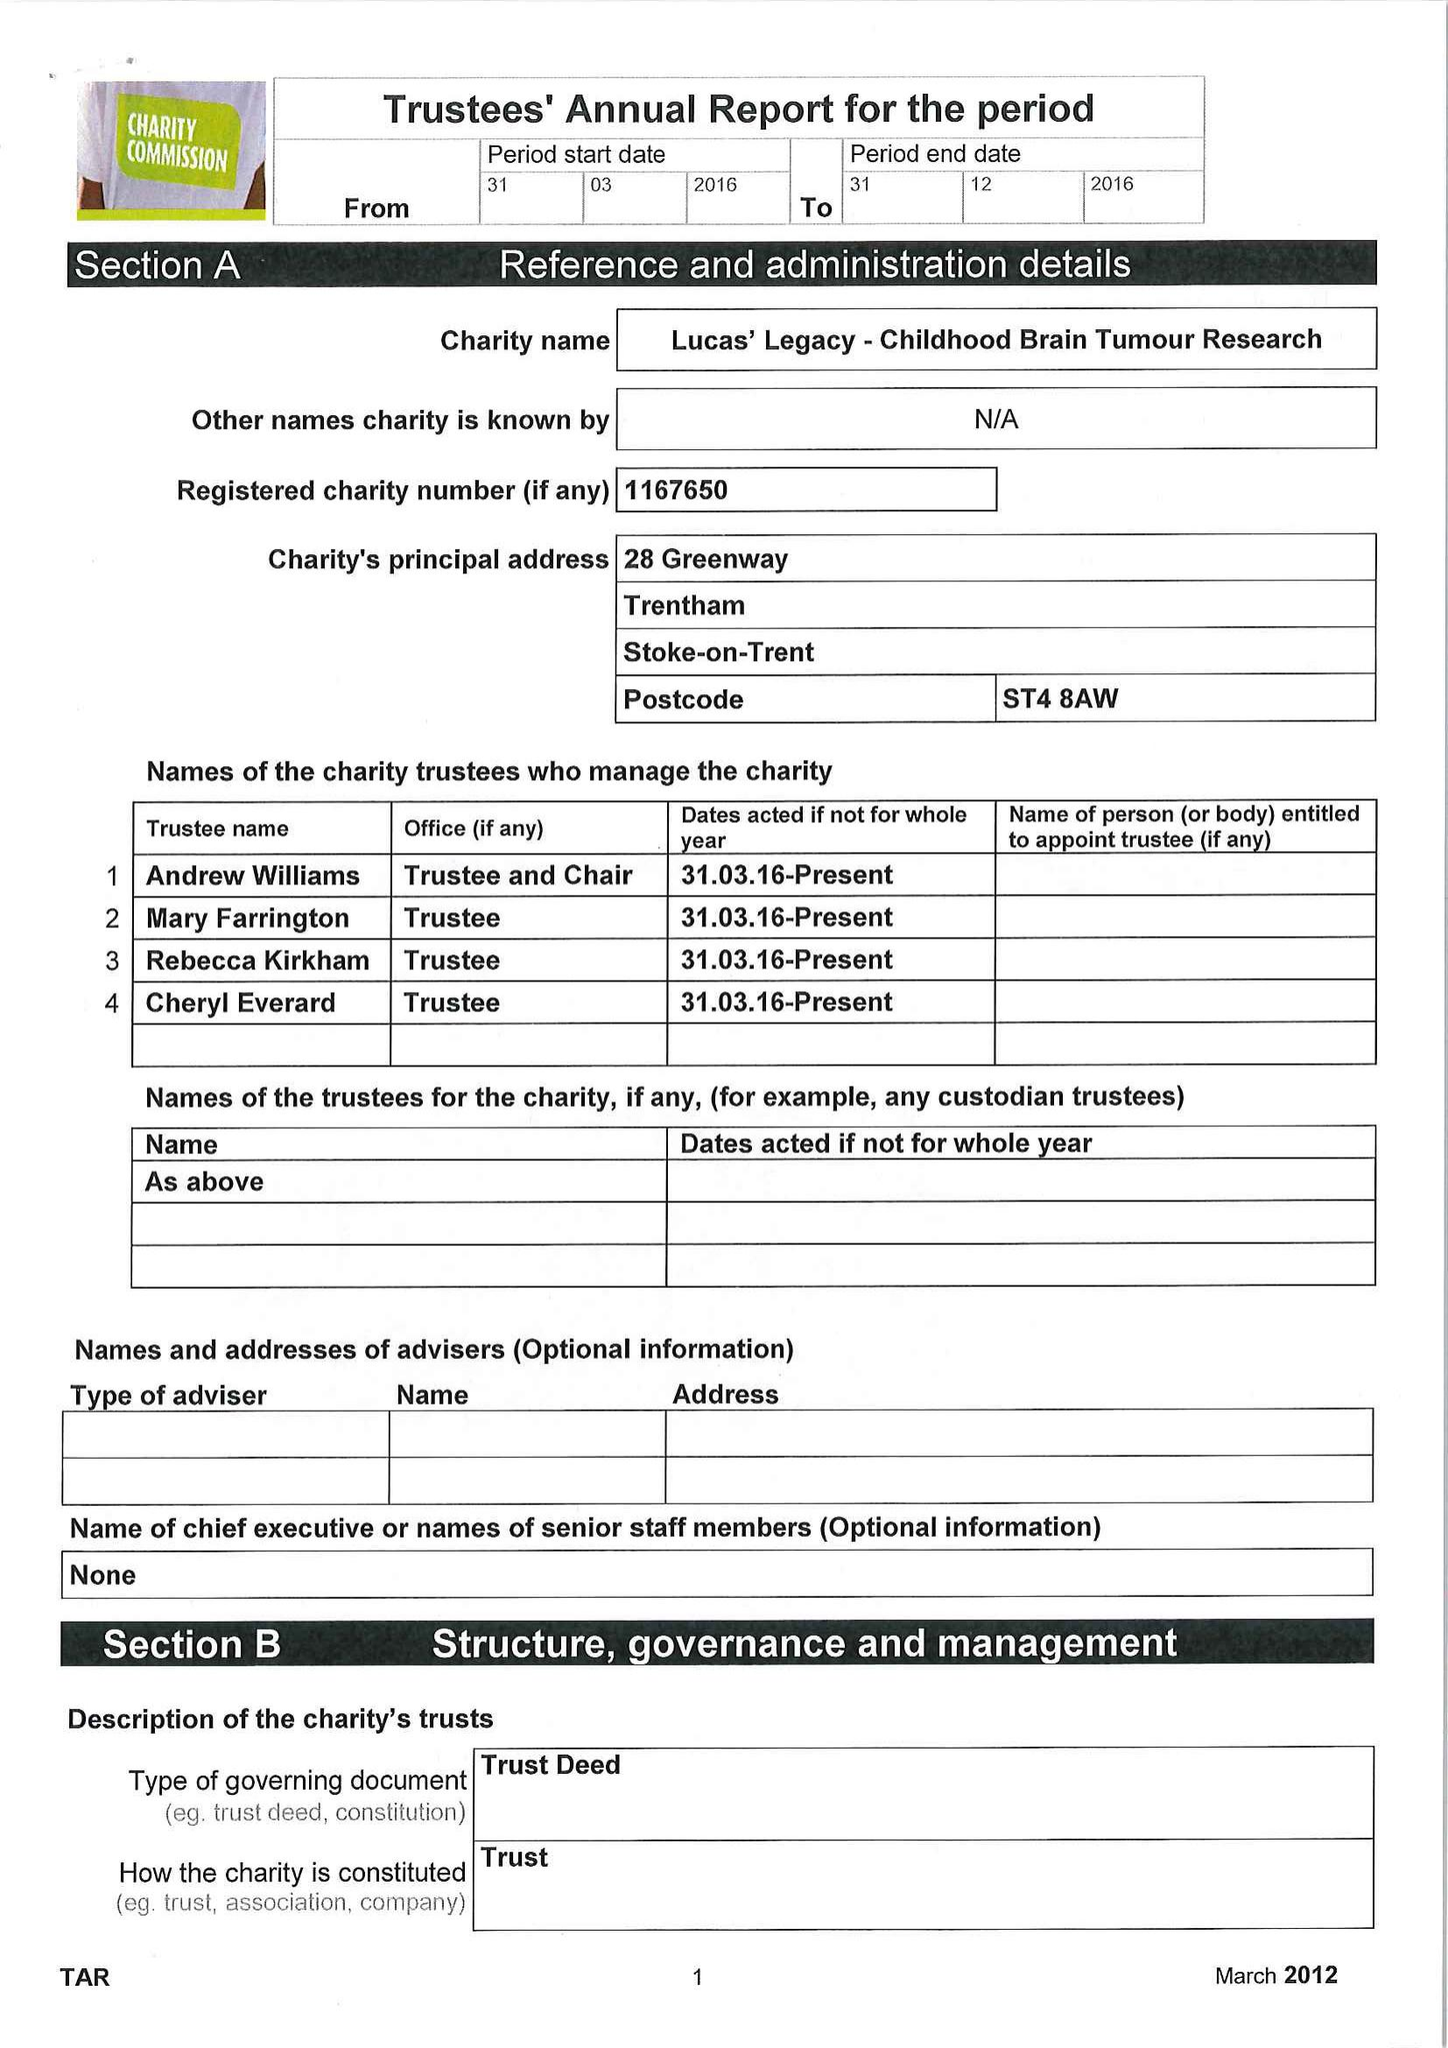What is the value for the charity_number?
Answer the question using a single word or phrase. 1167650 